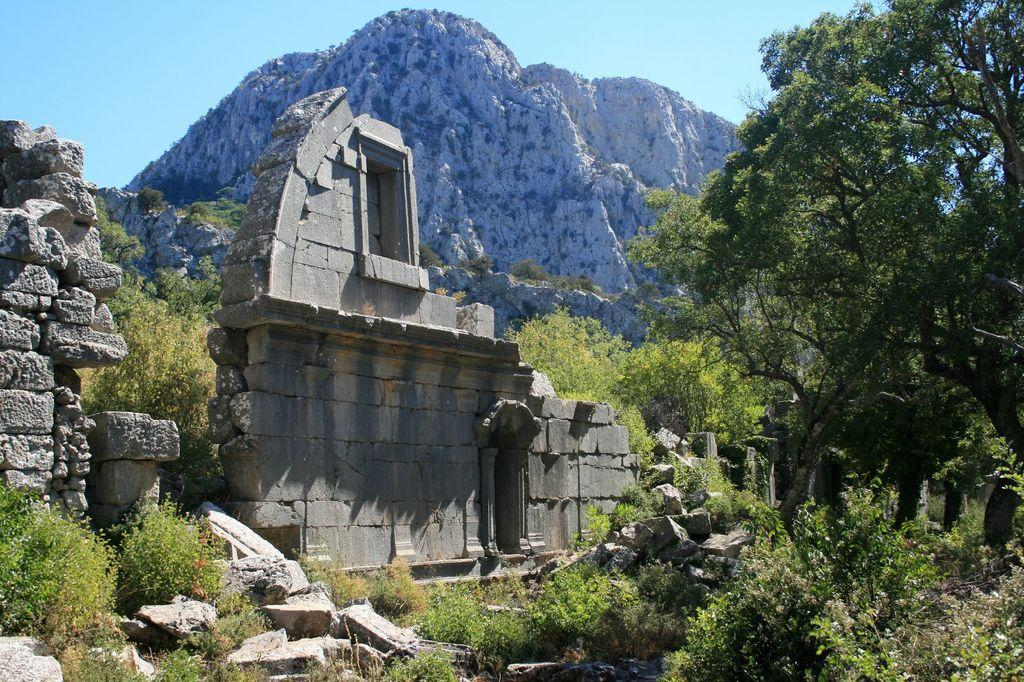What type of structure can be seen in the image? There is a wall in the image. What type of natural elements are present in the image? There are stones, trees, and rocks visible in the image. What can be seen in the background of the image? The sky is visible in the background of the image. What type of ornament is hanging from the tree in the image? There is no ornament hanging from the tree in the image; only stones, trees, and rocks are visible. 